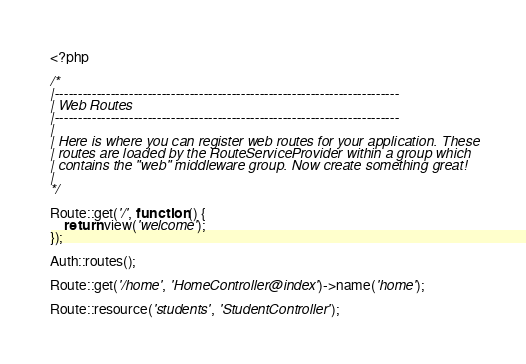<code> <loc_0><loc_0><loc_500><loc_500><_PHP_><?php

/*
|--------------------------------------------------------------------------
| Web Routes
|--------------------------------------------------------------------------
|
| Here is where you can register web routes for your application. These
| routes are loaded by the RouteServiceProvider within a group which
| contains the "web" middleware group. Now create something great!
|
*/

Route::get('/', function () {
    return view('welcome');
});

Auth::routes();

Route::get('/home', 'HomeController@index')->name('home');

Route::resource('students', 'StudentController');
</code> 